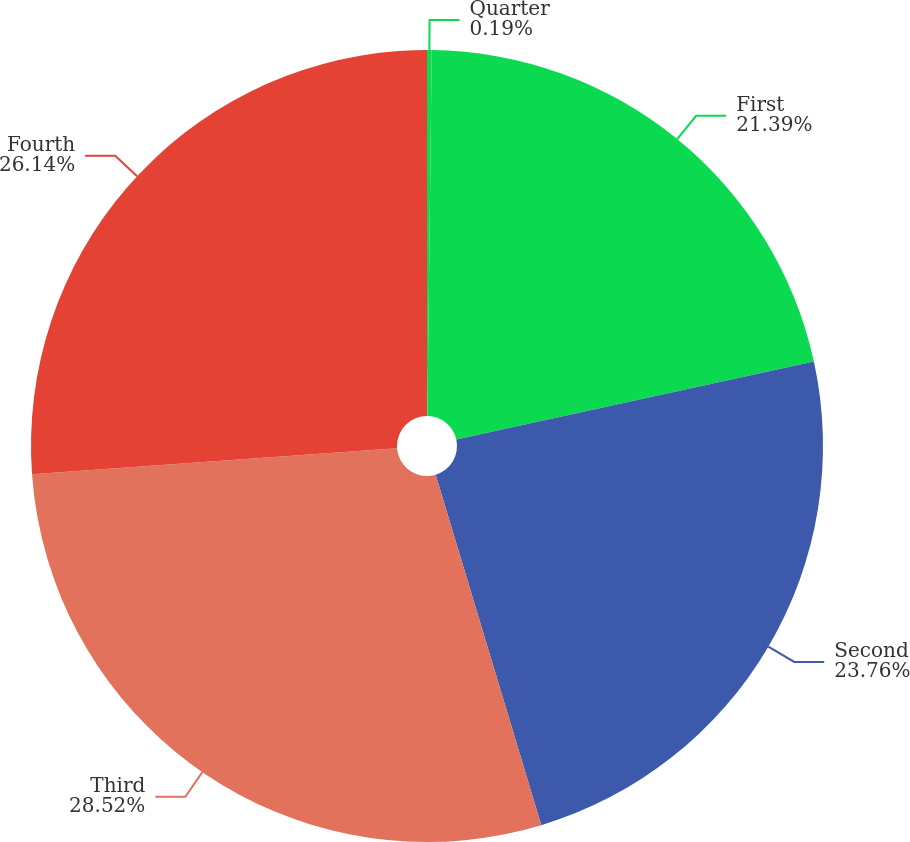Convert chart to OTSL. <chart><loc_0><loc_0><loc_500><loc_500><pie_chart><fcel>Quarter<fcel>First<fcel>Second<fcel>Third<fcel>Fourth<nl><fcel>0.19%<fcel>21.39%<fcel>23.76%<fcel>28.52%<fcel>26.14%<nl></chart> 